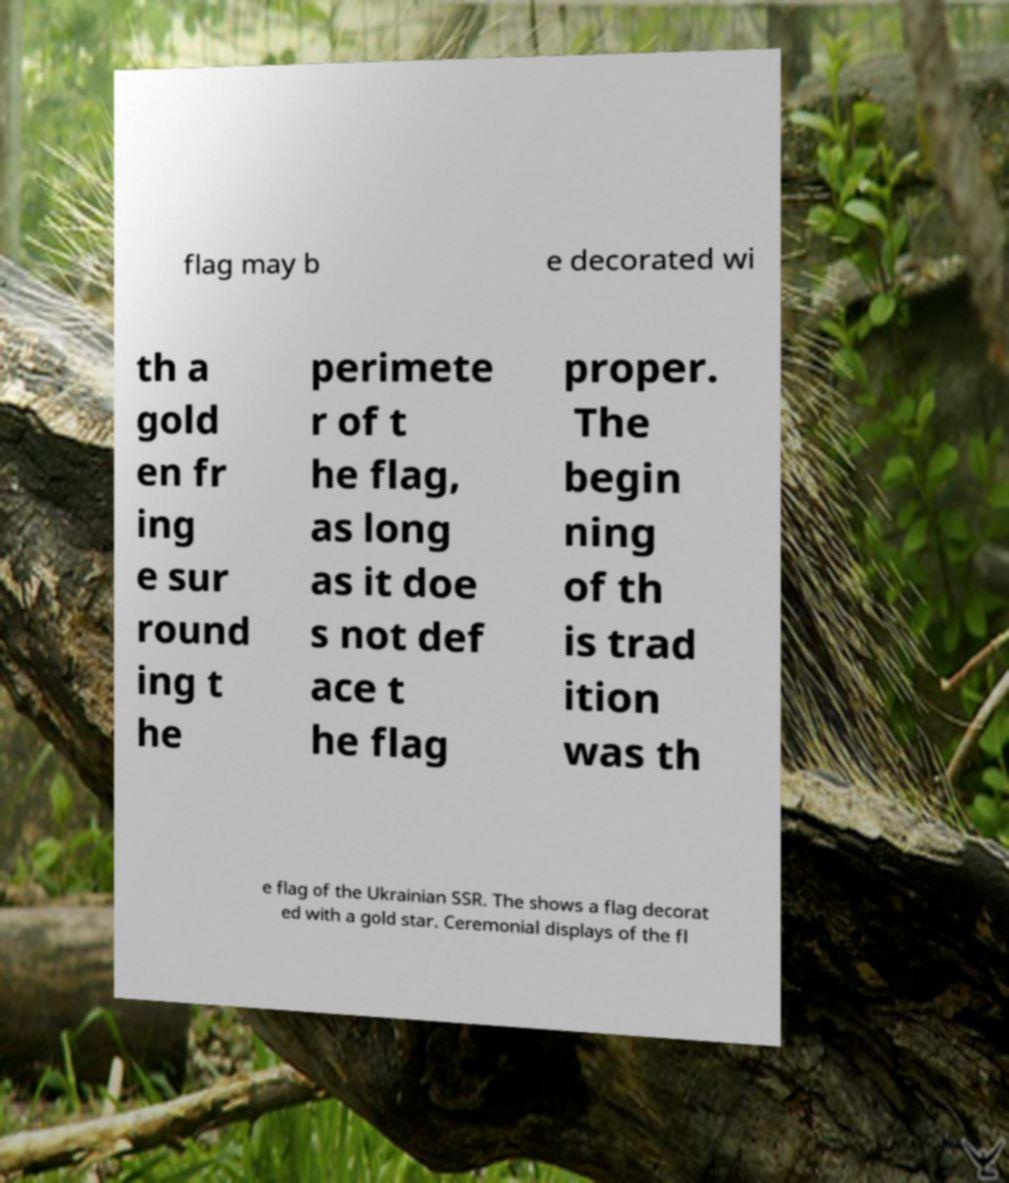Can you accurately transcribe the text from the provided image for me? flag may b e decorated wi th a gold en fr ing e sur round ing t he perimete r of t he flag, as long as it doe s not def ace t he flag proper. The begin ning of th is trad ition was th e flag of the Ukrainian SSR. The shows a flag decorat ed with a gold star. Ceremonial displays of the fl 